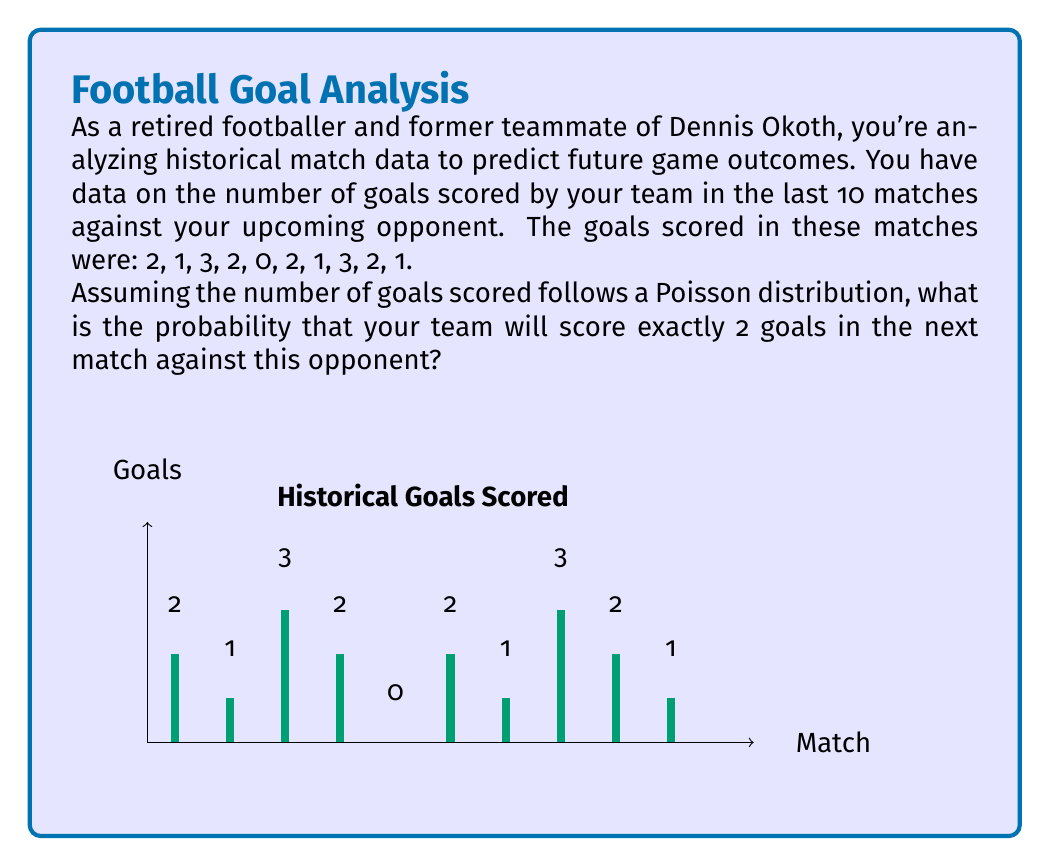Solve this math problem. To solve this problem, we'll follow these steps:

1) First, we need to calculate the average (λ) of goals scored in the past matches:

   $\lambda = \frac{2 + 1 + 3 + 2 + 0 + 2 + 1 + 3 + 2 + 1}{10} = \frac{17}{10} = 1.7$

2) The Poisson distribution probability mass function is:

   $P(X = k) = \frac{e^{-\lambda} \lambda^k}{k!}$

   where $k$ is the number of events (in this case, goals) we're interested in.

3) We want to find $P(X = 2)$, so we'll substitute $\lambda = 1.7$ and $k = 2$:

   $P(X = 2) = \frac{e^{-1.7} (1.7)^2}{2!}$

4) Let's calculate this step-by-step:
   
   $e^{-1.7} \approx 0.1827$
   
   $(1.7)^2 = 2.89$
   
   $2! = 2$

   $P(X = 2) = \frac{0.1827 \times 2.89}{2} \approx 0.2636$

5) Therefore, the probability of scoring exactly 2 goals in the next match is approximately 0.2636 or 26.36%.
Answer: 0.2636 